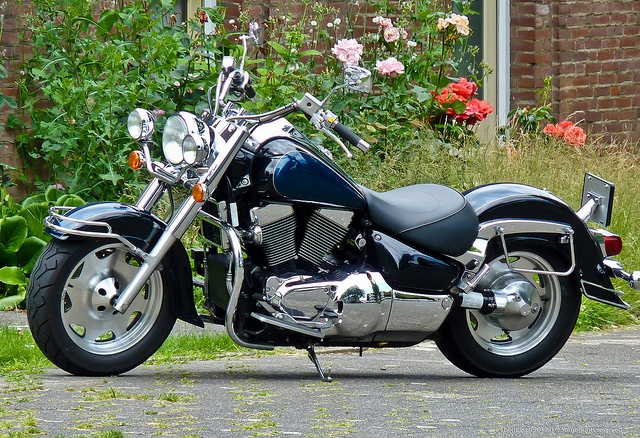Describe the objects in this image and their specific colors. I can see a motorcycle in maroon, black, darkgray, gray, and white tones in this image. 